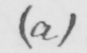What does this handwritten line say? ( a ) 